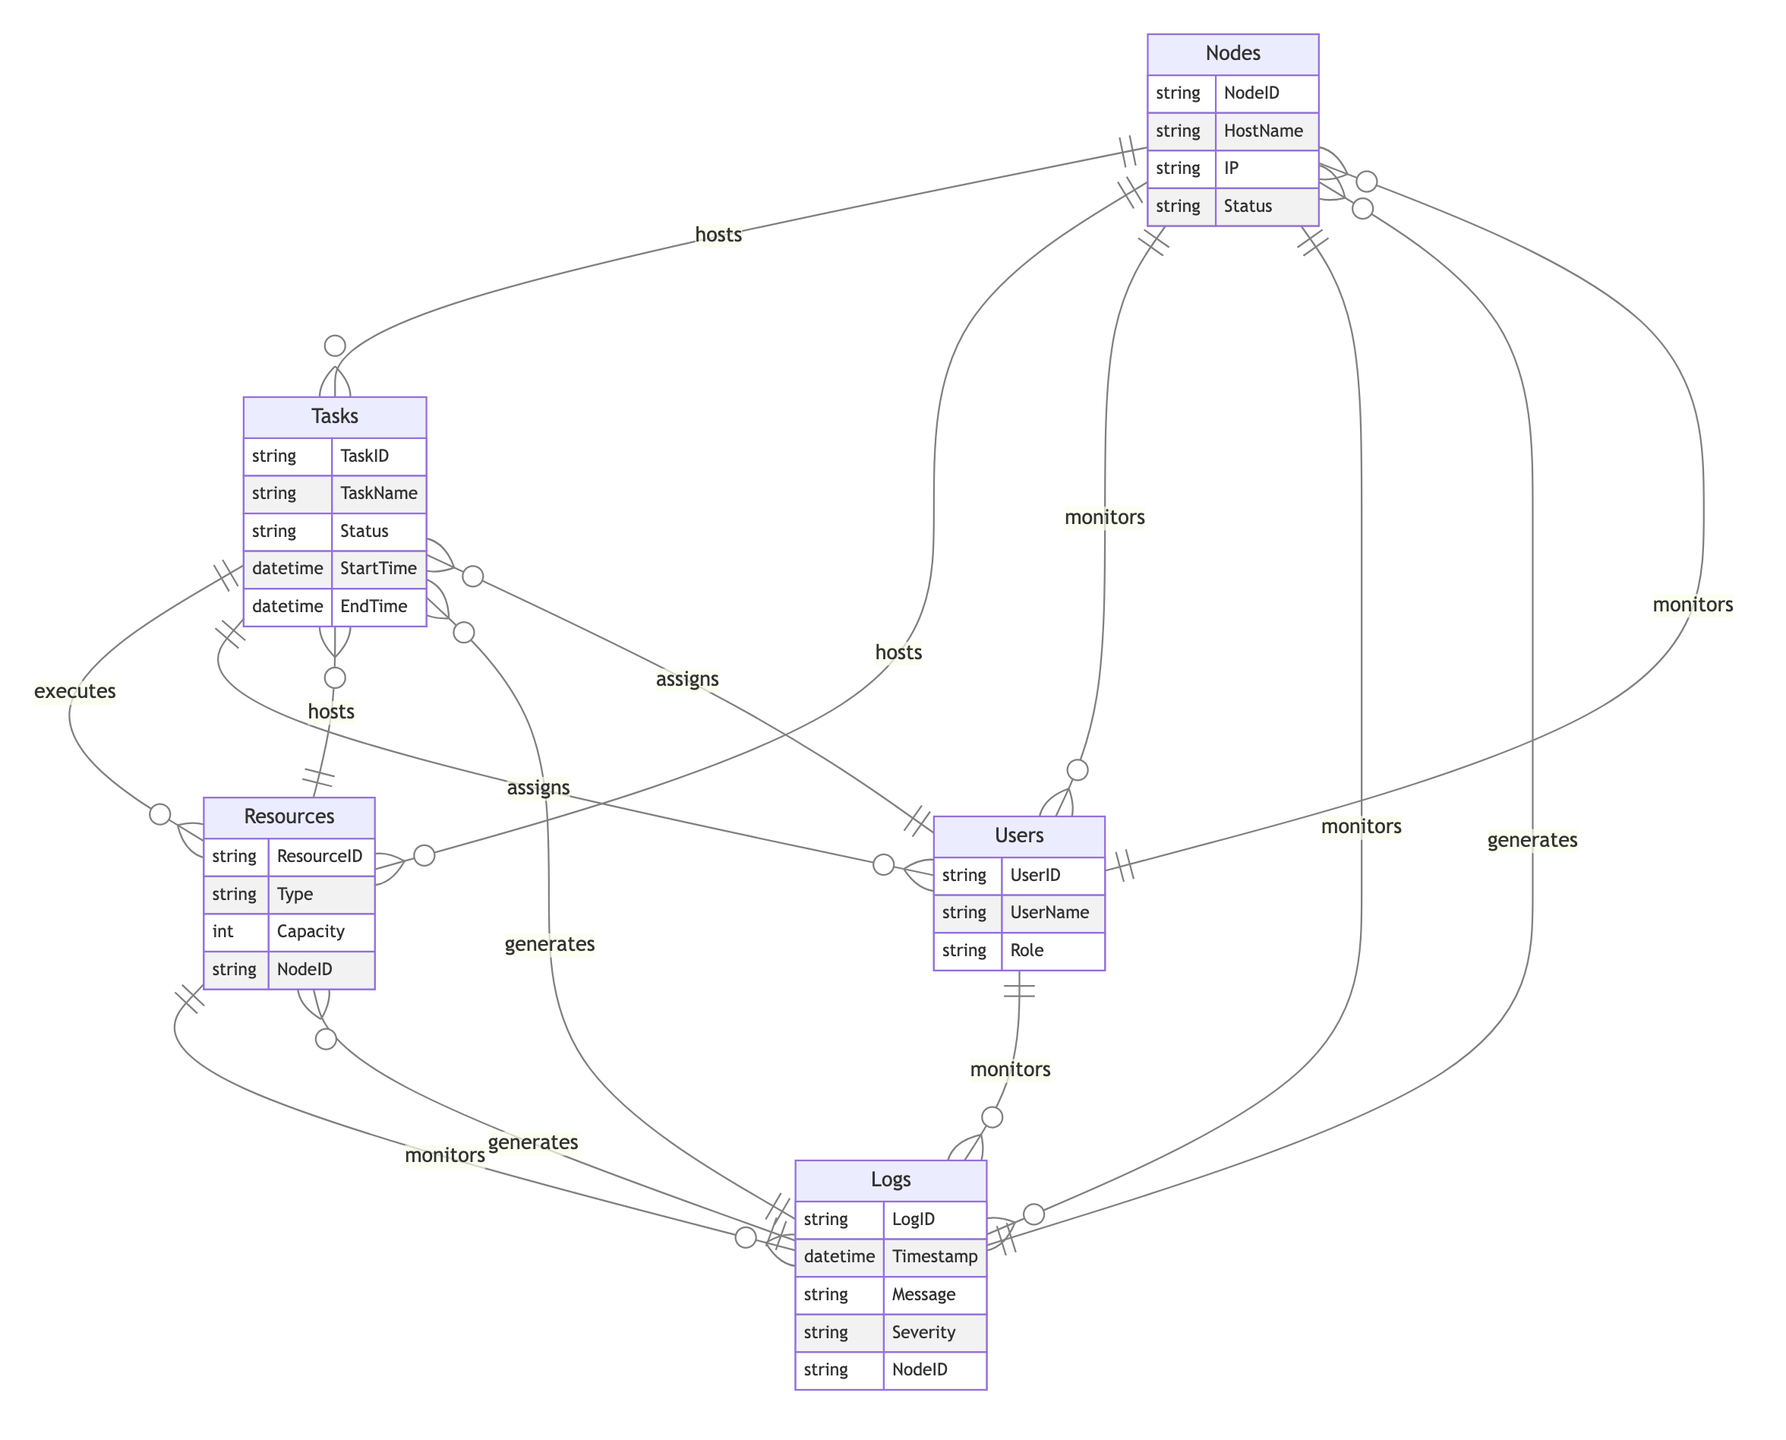What entities are represented in this diagram? The diagram includes five entities: Nodes, Tasks, Resources, Users, and Logs.
Answer: Nodes, Tasks, Resources, Users, Logs What relationship connects Users to Tasks? The relationship that connects Users to Tasks is "assigns," indicating that Users can assign Tasks.
Answer: assigns How many attributes does the Resources entity have? The Resources entity has four attributes: ResourceID, Type, Capacity, and NodeID.
Answer: four What does the Nodes entity monitor? The Nodes entity monitors Users and Logs.
Answer: Users, Logs Which entity executes Resources? The Tasks entity executes Resources based on the relationship defined in the diagram.
Answer: Tasks What is the primary function of the Logs entity? The Logs entity generates information regarding Nodes, Tasks, and Resources.
Answer: generates How are Nodes related to Tasks in the diagram? Nodes "host" Tasks, which indicates that they provide the necessary environment for the Tasks to run.
Answer: hosts Which attributes from the Users entity are present in the diagram? The attributes in the Users entity are UserID, UserName, and Role.
Answer: UserID, UserName, Role What type of information do Logs store? Logs store information such as LogID, Timestamp, Message, Severity, and NodeID.
Answer: LogID, Timestamp, Message, Severity, NodeID How many unique relationships are shown between the entities? The diagram shows multiple unique relationships, specifically ten distinct relationships among the five entities.
Answer: ten 